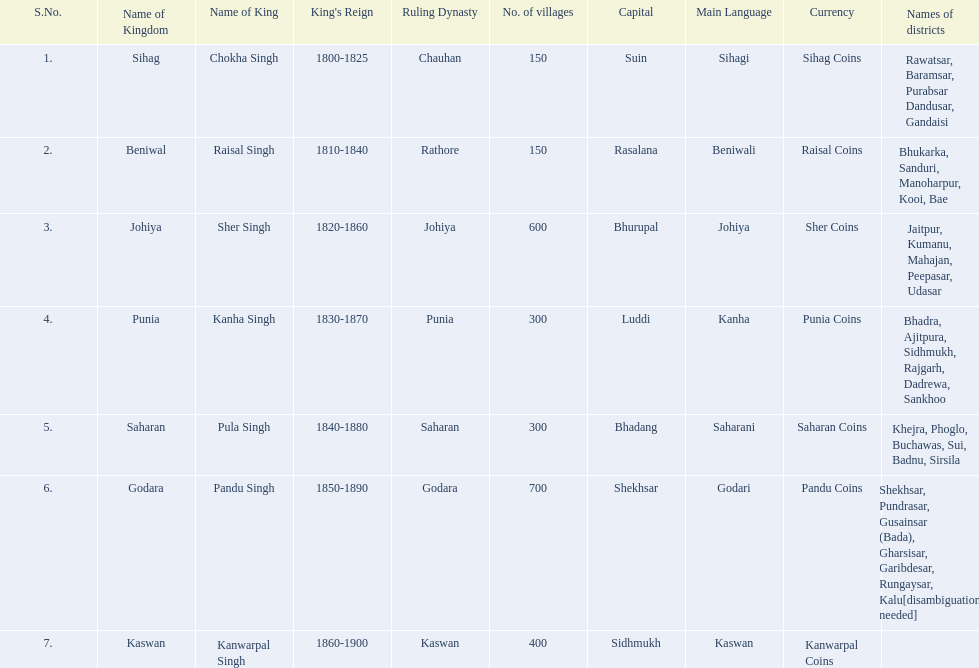What are all of the kingdoms? Sihag, Beniwal, Johiya, Punia, Saharan, Godara, Kaswan. How many villages do they contain? 150, 150, 600, 300, 300, 700, 400. How many are in godara? 700. Which kingdom comes next in highest amount of villages? Johiya. 